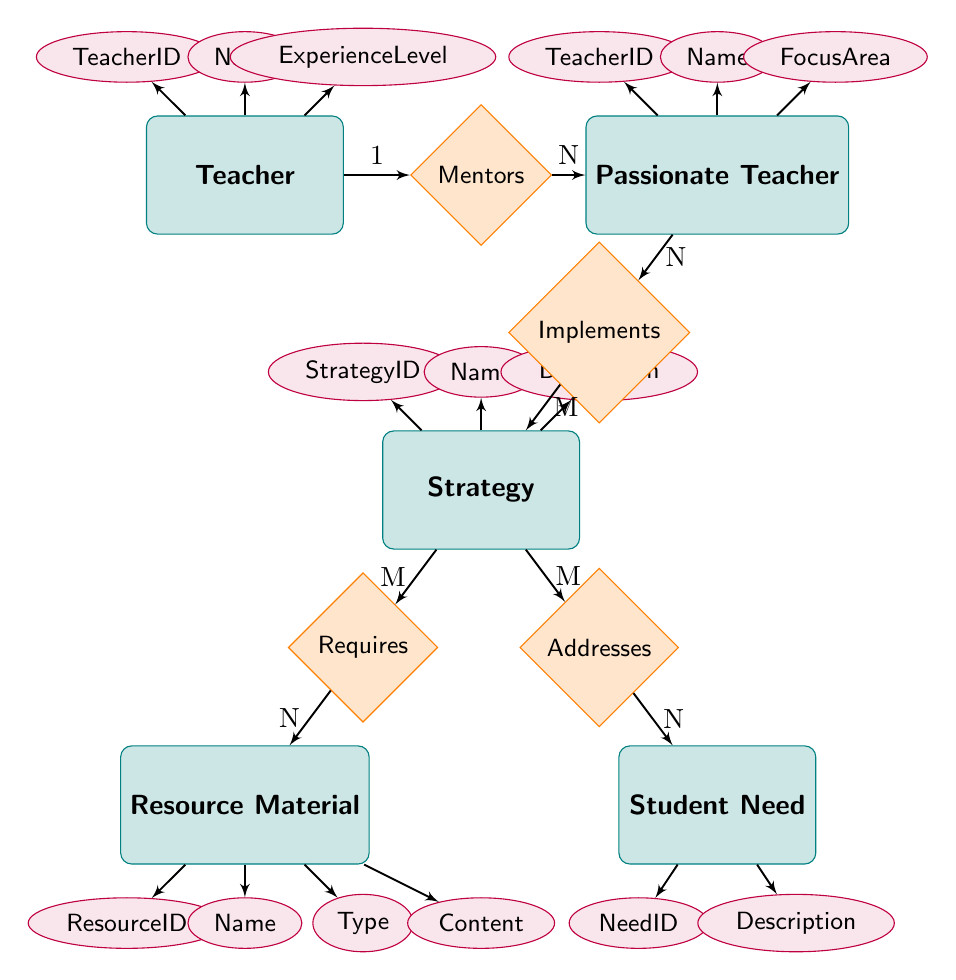What is the unique identifier for the Teacher entity? In the Teacher entity, the attribute "TeacherID" is specified as the first attribute, which serves as the unique identifier for each teacher.
Answer: TeacherID How many attributes does the Strategy entity have? The Strategy entity lists three attributes: StrategyID, Name, and Description. Counting these gives us a total of three attributes.
Answer: 3 What relationship exists between Teacher and Passionate Teacher? The diagram shows that a Teacher "mentors" Passionate Teachers, indicating a one-to-many relationship where one teacher can mentor multiple passionate teachers.
Answer: Mentors What type of relationship is between Strategy and Resource Material? The relationship between Strategy and Resource Material is classified as many-to-many, allowing multiple strategies to require multiple resource materials.
Answer: Many-to-many Which entity does Student Need address? The diagram shows that the entity Student Need is addressed by the Strategy entity, indicating that strategies aim to meet various student needs.
Answer: Strategy How many Student Needs can a single Strategy address? The relationship type between Strategy and Student Need is many-to-many. Thus, a single strategy can address multiple student needs.
Answer: Multiple Which entity is implemented by the Passionate Teacher? According to the diagram, the Passionate Teacher implements the Strategy entity, highlighting the role of passionate teachers in applying various strategies.
Answer: Strategy What does the Resource Material contain? The Resource Material entity specifies an attribute called "Content," indicating that it contains educational materials or information used for teaching purposes.
Answer: Content How many entities are involved in the diagram? By counting the distinct entities labeled in the diagram, we find five entities: Teacher, Passionate Teacher, Strategy, Resource Material, and Student Need.
Answer: 5 